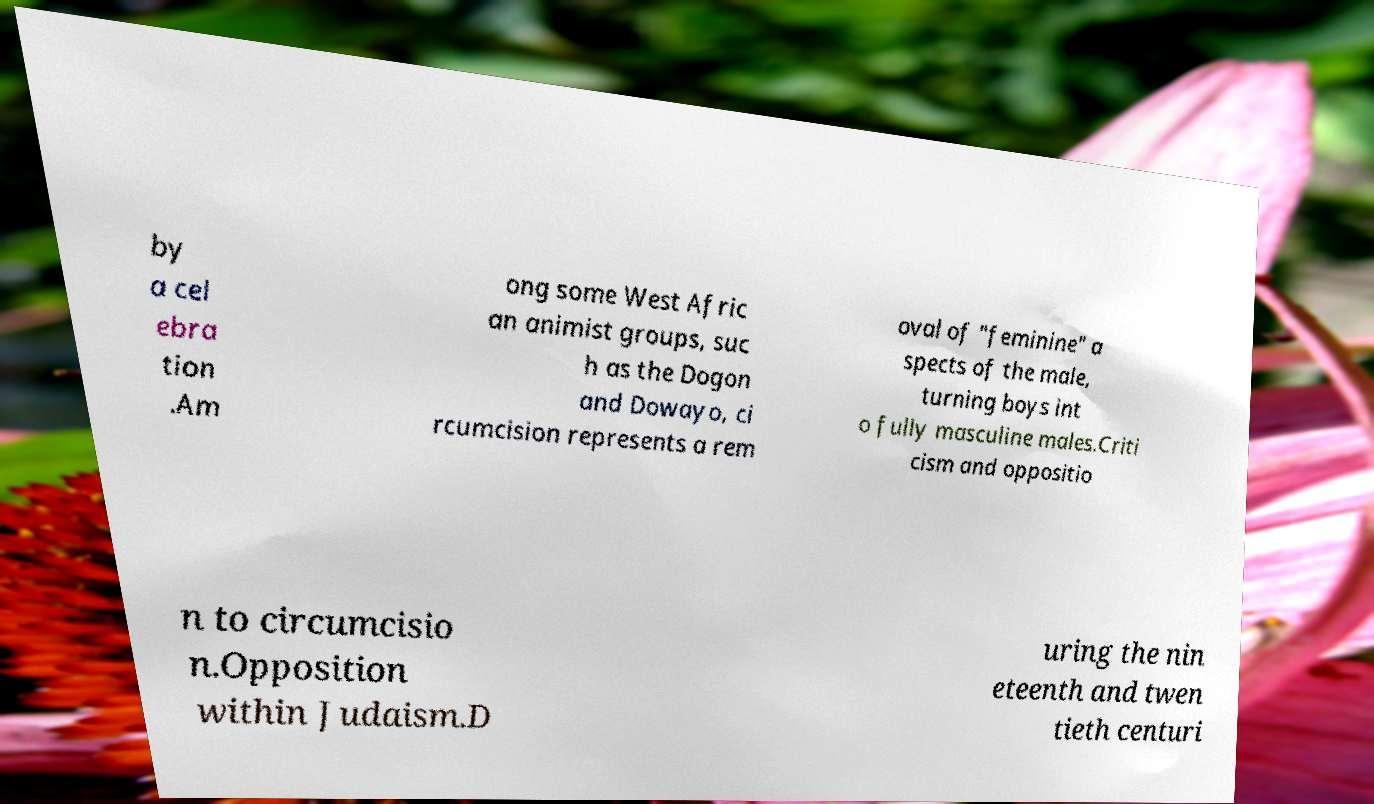There's text embedded in this image that I need extracted. Can you transcribe it verbatim? by a cel ebra tion .Am ong some West Afric an animist groups, suc h as the Dogon and Dowayo, ci rcumcision represents a rem oval of "feminine" a spects of the male, turning boys int o fully masculine males.Criti cism and oppositio n to circumcisio n.Opposition within Judaism.D uring the nin eteenth and twen tieth centuri 